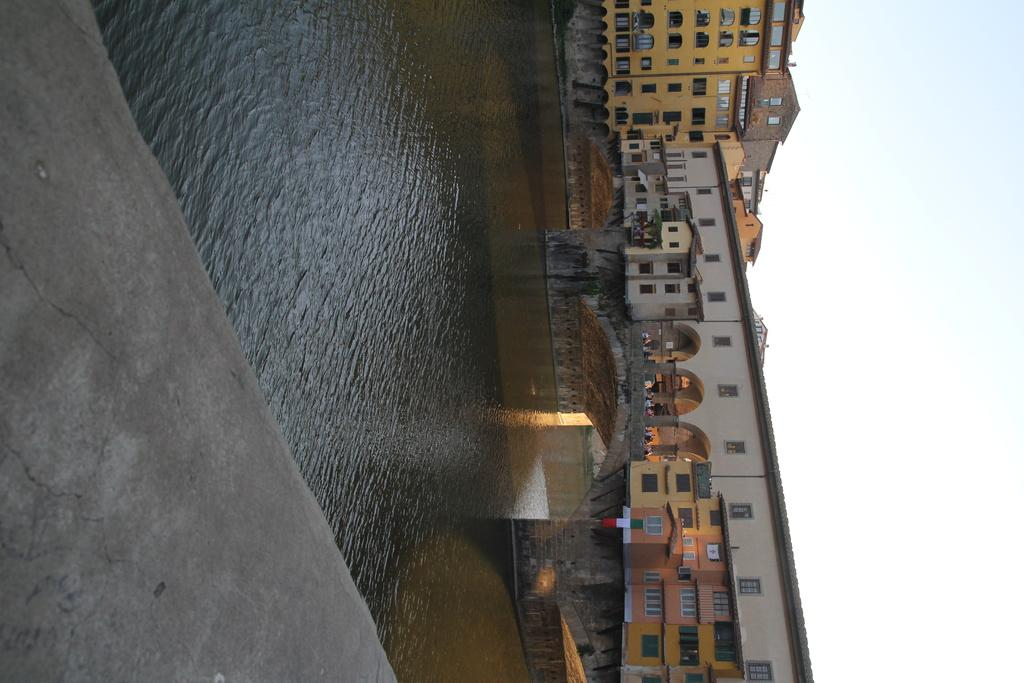What type of surface is visible in the foreground of the image? There is a pavement in the image. What natural feature is located behind the pavement? There is a river behind the pavement. How can people or vehicles cross the river in the image? There is a bridge across the river in the image. What structures can be seen in the distance in the image? There are buildings in the background of the image. How many boys are playing with iron in the image? There are no boys or iron present in the image. 